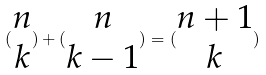Convert formula to latex. <formula><loc_0><loc_0><loc_500><loc_500>( \begin{matrix} n \\ k \end{matrix} ) + ( \begin{matrix} n \\ k - 1 \end{matrix} ) = ( \begin{matrix} n + 1 \\ k \end{matrix} )</formula> 